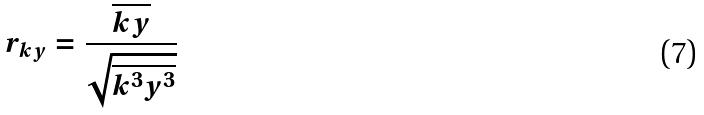Convert formula to latex. <formula><loc_0><loc_0><loc_500><loc_500>r _ { k y } = \frac { \overline { k y } } { \sqrt { \overline { k ^ { 3 } } \overline { y ^ { 3 } } } }</formula> 